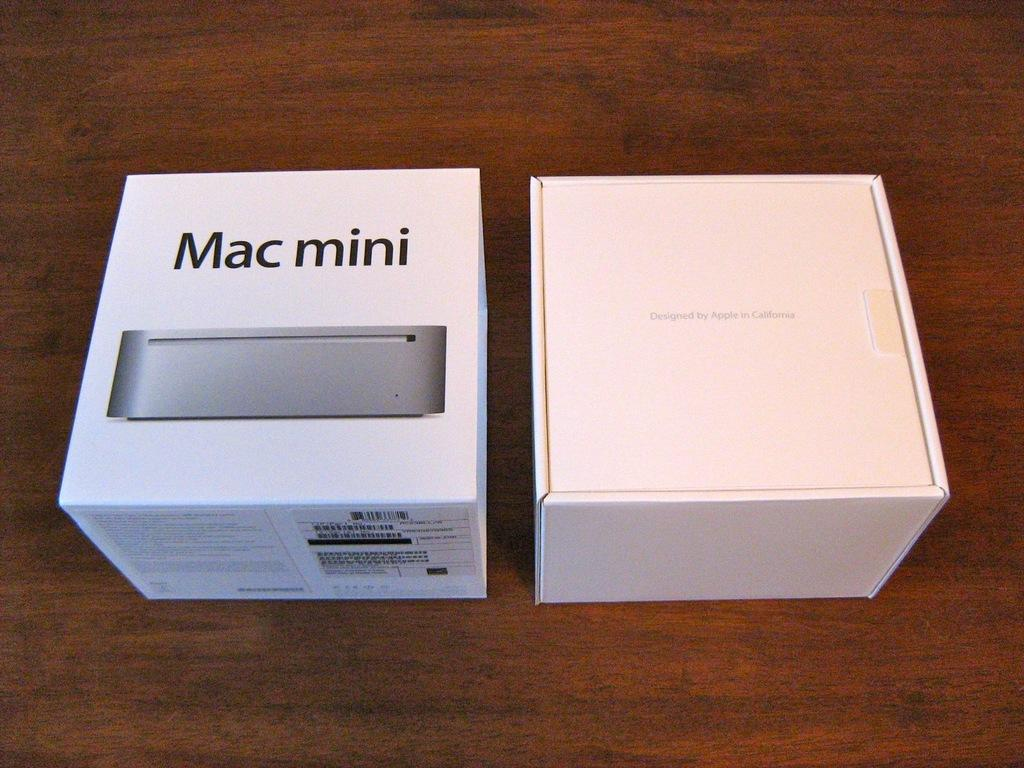<image>
Provide a brief description of the given image. Two small square boxes with one Mac Mini and the other with the other from Apple. 